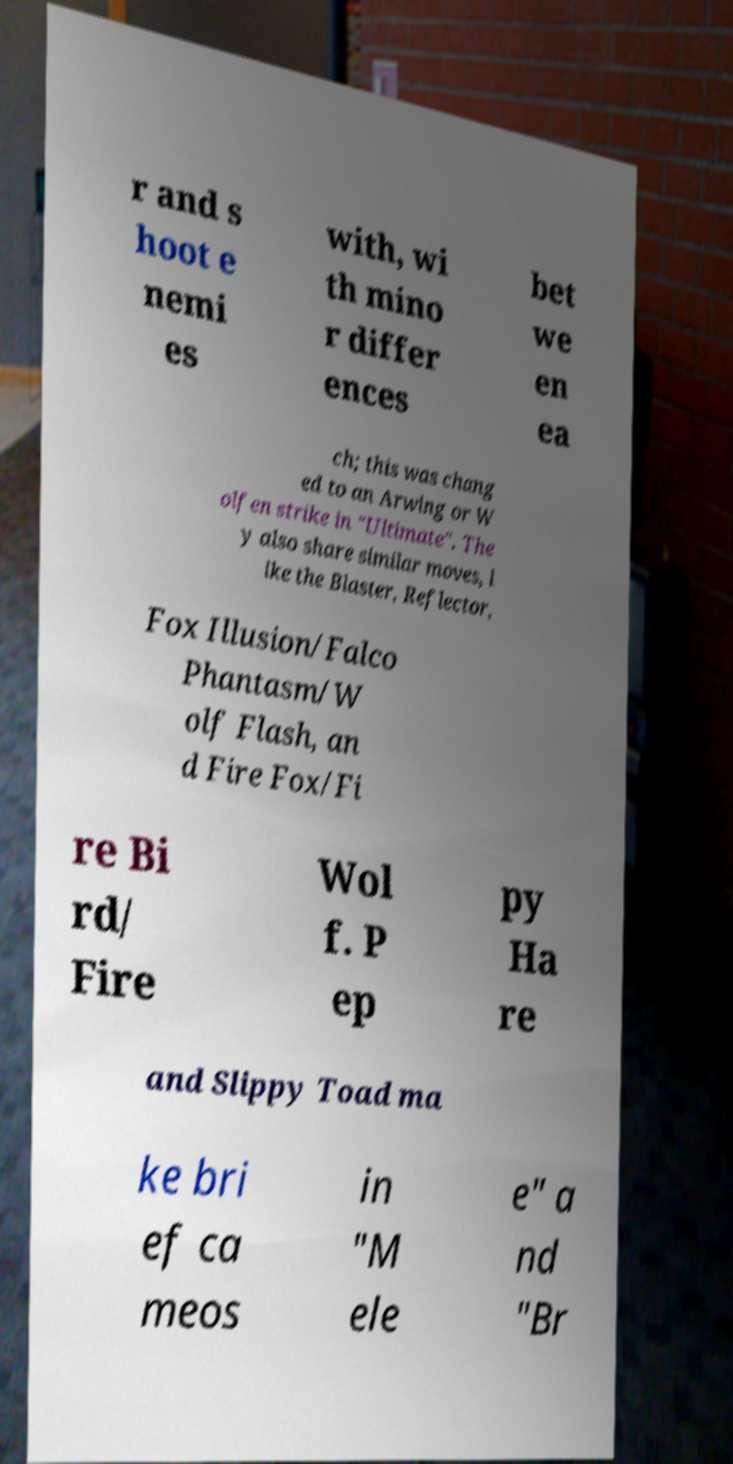I need the written content from this picture converted into text. Can you do that? r and s hoot e nemi es with, wi th mino r differ ences bet we en ea ch; this was chang ed to an Arwing or W olfen strike in "Ultimate". The y also share similar moves, l ike the Blaster, Reflector, Fox Illusion/Falco Phantasm/W olf Flash, an d Fire Fox/Fi re Bi rd/ Fire Wol f. P ep py Ha re and Slippy Toad ma ke bri ef ca meos in "M ele e" a nd "Br 